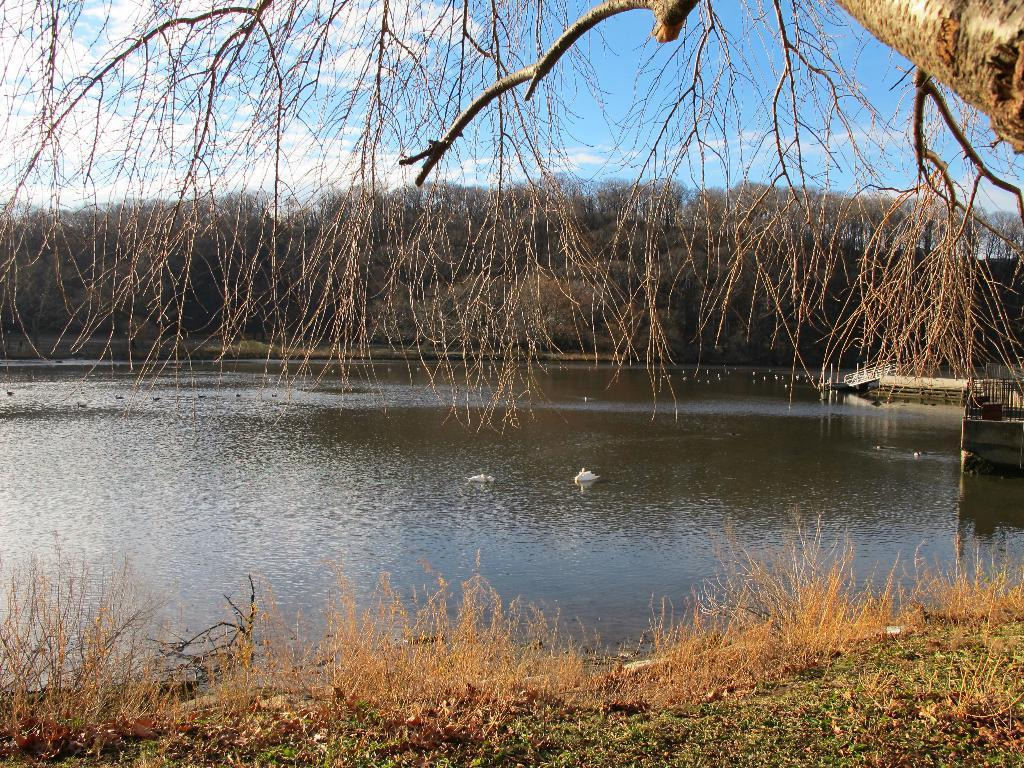What is the primary element visible in the image? There is water in the image. What type of vegetation can be seen in the image? There are trees and grass in the image. What is visible in the background of the image? The sky is visible in the background of the image. What can be observed in the sky? Clouds are present in the sky. What advice is the wren giving to the trees in the image? There is no wren present in the image, so it cannot provide any advice to the trees. 